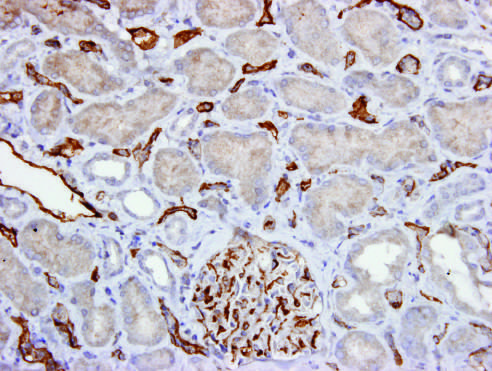does the immunoperoxidase stain show c4d deposition in peritubular capillaries and a glomerulus?
Answer the question using a single word or phrase. Yes 